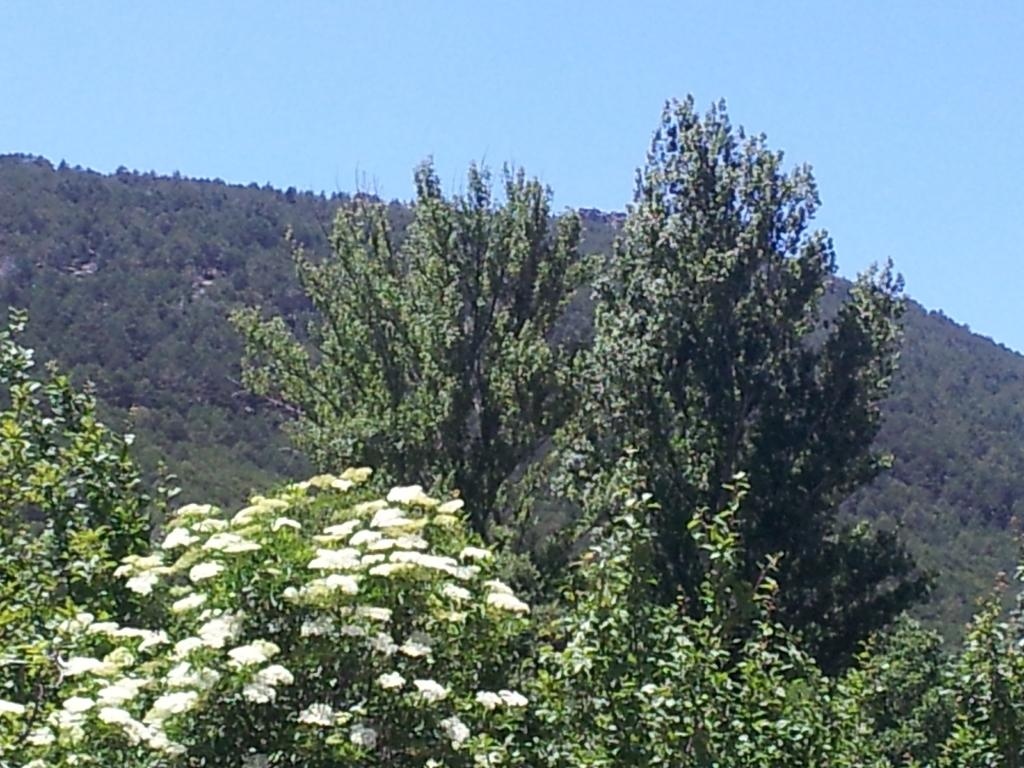What type of vegetation can be seen in the image? There are trees in the image. What other natural elements are present in the image? There are flowers in the image. What is visible at the top of the image? The sky is visible at the top of the image. How many chickens are visible in the image? There are no chickens present in the image. Can you describe the plane flying in the sky in the image? There is no plane visible in the sky in the image. 